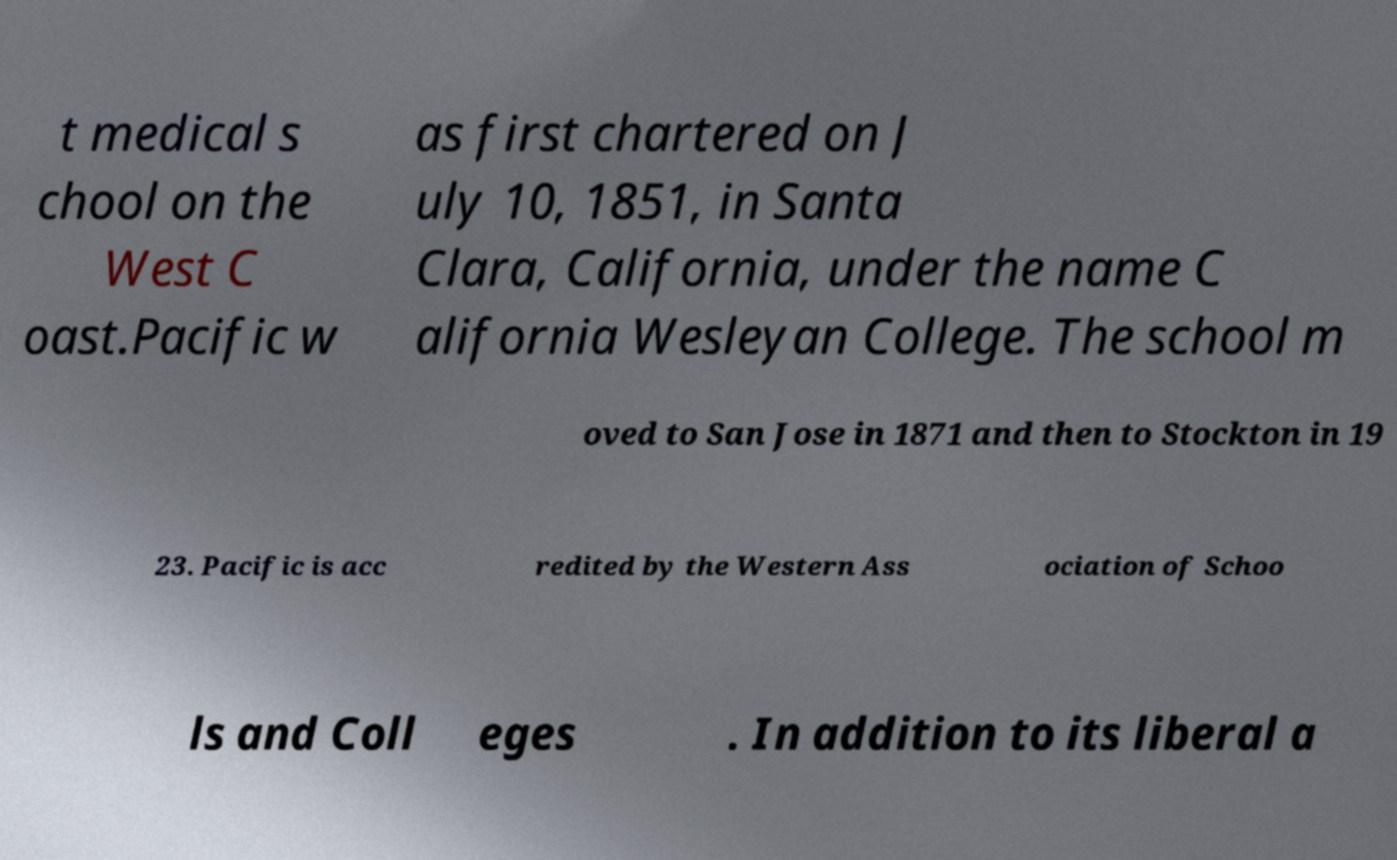Could you extract and type out the text from this image? t medical s chool on the West C oast.Pacific w as first chartered on J uly 10, 1851, in Santa Clara, California, under the name C alifornia Wesleyan College. The school m oved to San Jose in 1871 and then to Stockton in 19 23. Pacific is acc redited by the Western Ass ociation of Schoo ls and Coll eges . In addition to its liberal a 